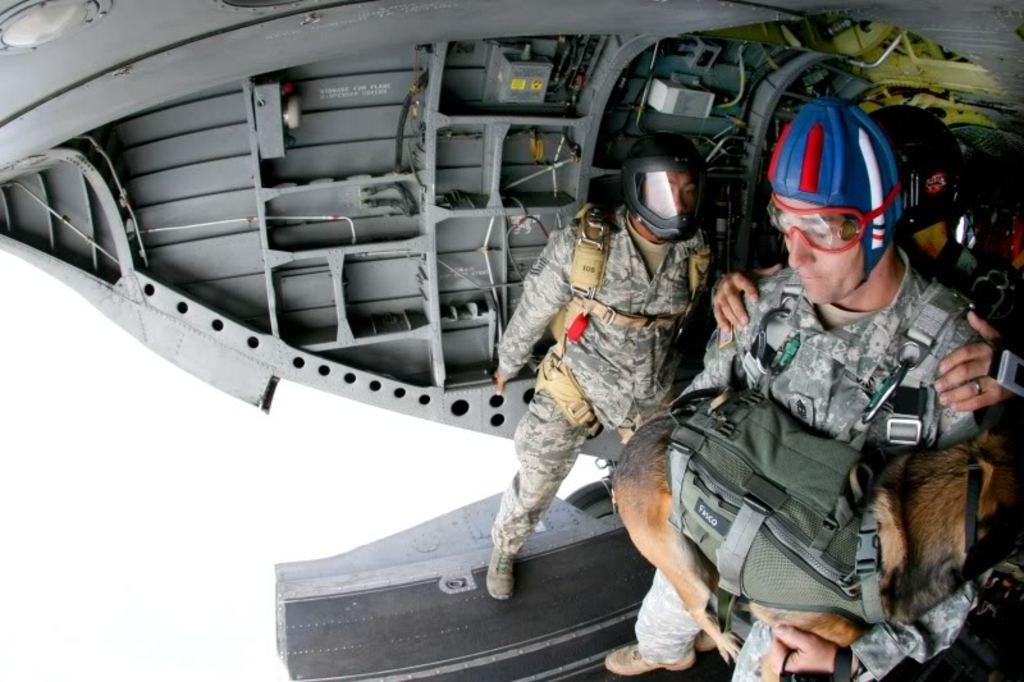How many people are in the image? There is a group of people in the image. What are the people wearing on their heads? The people are wearing helmets. What are the people standing on? The people are standing on a surface. Who is holding a dog in the image? One person is holding a dog in the image. What objects can be seen that are typically used for construction or repair? There are tools visible in the image. What type of material can be seen that is used for structural support? There are metal rods visible in the image. How many cacti are visible in the image? There are no cacti present in the image. What type of boot is the person wearing on their left foot? There is no boot visible on anyone's foot in the image. 